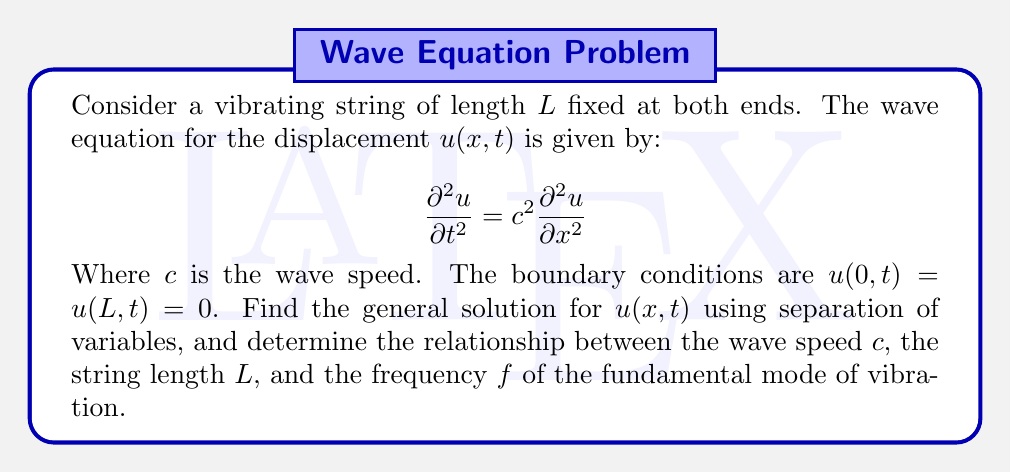What is the answer to this math problem? Let's approach this step-by-step:

1) We start by assuming a solution of the form $u(x,t) = X(x)T(t)$.

2) Substituting this into the wave equation:

   $$X(x)\frac{d^2T}{dt^2} = c^2T(t)\frac{d^2X}{dx^2}$$

3) Dividing both sides by $c^2X(x)T(t)$:

   $$\frac{1}{c^2T}\frac{d^2T}{dt^2} = \frac{1}{X}\frac{d^2X}{dx^2}$$

4) Since the left side depends only on $t$ and the right side only on $x$, both must equal a constant, say $-k^2$:

   $$\frac{1}{c^2T}\frac{d^2T}{dt^2} = -k^2 = \frac{1}{X}\frac{d^2X}{dx^2}$$

5) This gives us two ordinary differential equations:

   $$\frac{d^2T}{dt^2} + c^2k^2T = 0$$
   $$\frac{d^2X}{dx^2} + k^2X = 0$$

6) The general solutions are:

   $$T(t) = A\cos(ckt) + B\sin(ckt)$$
   $$X(x) = C\cos(kx) + D\sin(kx)$$

7) Applying the boundary conditions:

   $X(0) = 0$ implies $C = 0$
   $X(L) = 0$ implies $D\sin(kL) = 0$

8) For non-trivial solutions, we must have $\sin(kL) = 0$, which means:

   $$kL = n\pi, \quad n = 1,2,3,...$$

9) Therefore, $k = \frac{n\pi}{L}$, and the general solution is:

   $$u(x,t) = \sum_{n=1}^{\infty} (A_n\cos(\frac{n\pi c}{L}t) + B_n\sin(\frac{n\pi c}{L}t))\sin(\frac{n\pi x}{L})$$

10) The fundamental mode corresponds to $n=1$. Its frequency $f$ is related to $\omega = \frac{\pi c}{L}$ by $\omega = 2\pi f$. Therefore:

    $$f = \frac{c}{2L}$$

This gives us the relationship between the wave speed $c$, the string length $L$, and the frequency $f$ of the fundamental mode.
Answer: $u(x,t) = \sum_{n=1}^{\infty} (A_n\cos(\frac{n\pi c}{L}t) + B_n\sin(\frac{n\pi c}{L}t))\sin(\frac{n\pi x}{L})$; $f = \frac{c}{2L}$ 